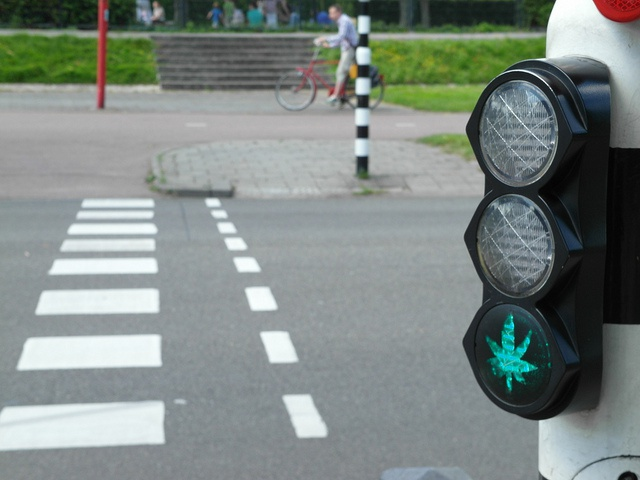Describe the objects in this image and their specific colors. I can see traffic light in black, gray, and darkgray tones, bicycle in black, gray, darkgray, and brown tones, people in black, darkgray, lightgray, and gray tones, people in black and teal tones, and people in black, gray, darkgray, and teal tones in this image. 